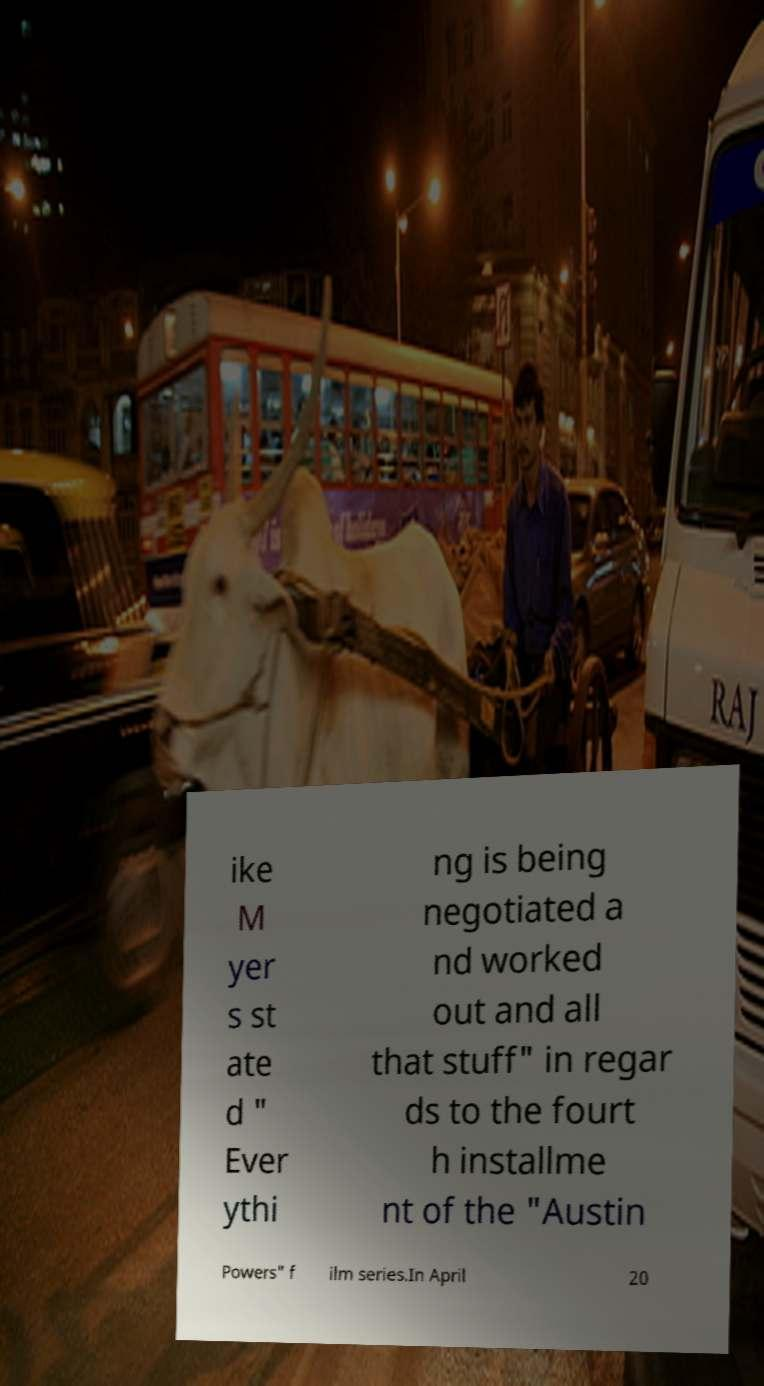Could you assist in decoding the text presented in this image and type it out clearly? ike M yer s st ate d " Ever ythi ng is being negotiated a nd worked out and all that stuff" in regar ds to the fourt h installme nt of the "Austin Powers" f ilm series.In April 20 